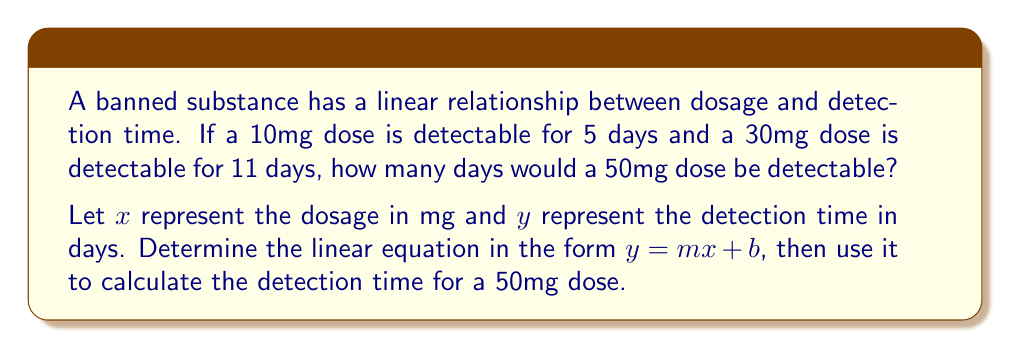Provide a solution to this math problem. 1. To find the linear equation, we need to calculate the slope $(m)$ and y-intercept $(b)$.

2. Calculate the slope:
   $m = \frac{y_2 - y_1}{x_2 - x_1} = \frac{11 - 5}{30 - 10} = \frac{6}{20} = 0.3$

3. Use the point-slope form with $(x_1, y_1) = (10, 5)$:
   $y - 5 = 0.3(x - 10)$

4. Simplify to get the equation in slope-intercept form:
   $y = 0.3x - 3 + 5$
   $y = 0.3x + 2$

5. Now we have the linear equation: $y = 0.3x + 2$

6. To find the detection time for a 50mg dose, substitute $x = 50$:
   $y = 0.3(50) + 2$
   $y = 15 + 2 = 17$

Therefore, a 50mg dose would be detectable for 17 days.
Answer: 17 days 